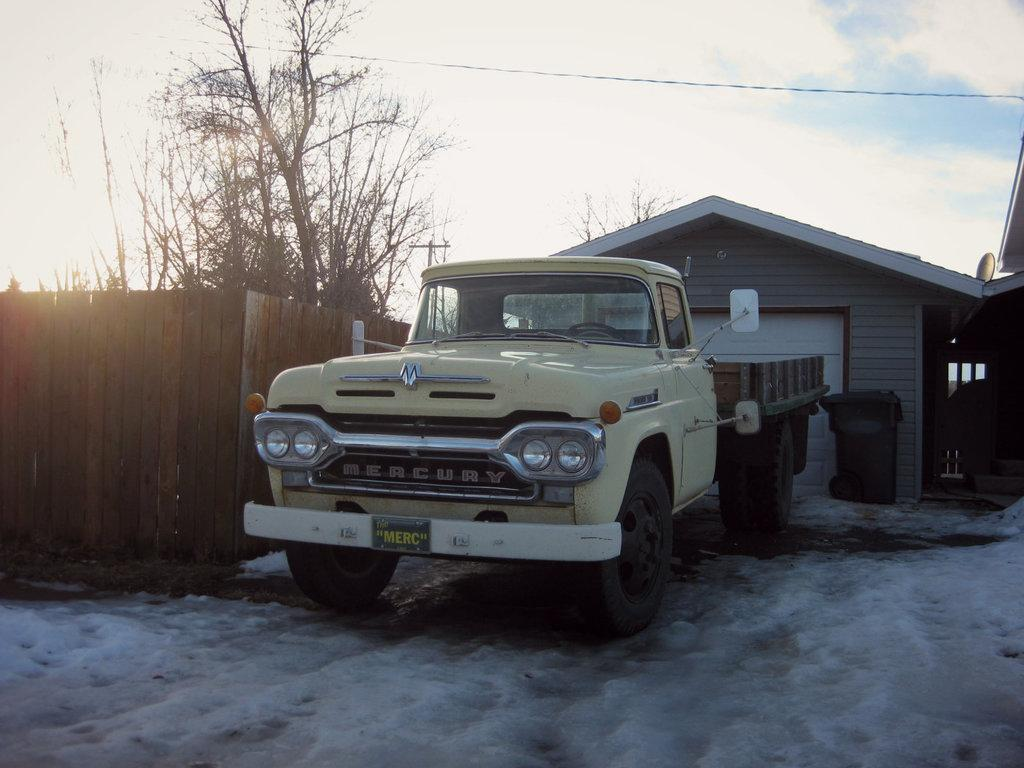<image>
Describe the image concisely. An old, yellow Mercury pickup truck sitting in front of a garage. 